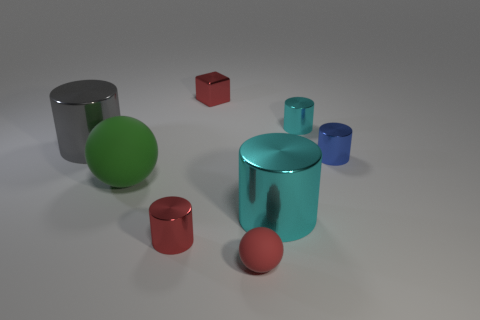What material is the ball that is the same size as the cube?
Give a very brief answer. Rubber. There is a metal block; does it have the same size as the cyan object in front of the large gray cylinder?
Offer a very short reply. No. How many rubber objects are either big green cylinders or gray cylinders?
Offer a very short reply. 0. What number of large gray metallic things have the same shape as the green object?
Provide a succinct answer. 0. There is a tiny block that is the same color as the tiny matte thing; what is it made of?
Make the answer very short. Metal. Is the size of the cyan metal object that is in front of the blue metallic cylinder the same as the red metallic cube that is behind the gray cylinder?
Offer a very short reply. No. What shape is the red metal thing that is behind the small blue metal cylinder?
Offer a terse response. Cube. What material is the small cyan object that is the same shape as the big cyan thing?
Ensure brevity in your answer.  Metal. Is the size of the cube to the left of the blue cylinder the same as the blue metal thing?
Your answer should be very brief. Yes. How many tiny cyan cylinders are in front of the big gray cylinder?
Offer a very short reply. 0. 